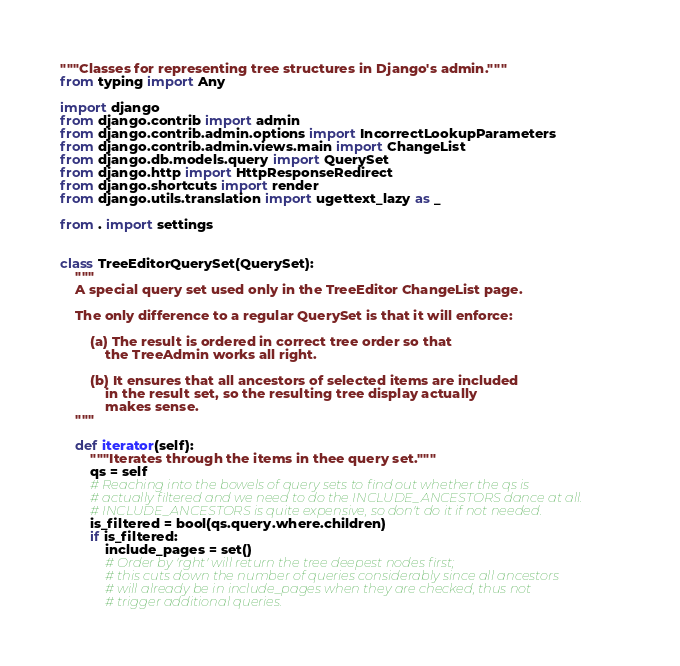<code> <loc_0><loc_0><loc_500><loc_500><_Python_>"""Classes for representing tree structures in Django's admin."""
from typing import Any

import django
from django.contrib import admin
from django.contrib.admin.options import IncorrectLookupParameters
from django.contrib.admin.views.main import ChangeList
from django.db.models.query import QuerySet
from django.http import HttpResponseRedirect
from django.shortcuts import render
from django.utils.translation import ugettext_lazy as _

from . import settings


class TreeEditorQuerySet(QuerySet):
    """
    A special query set used only in the TreeEditor ChangeList page.

    The only difference to a regular QuerySet is that it will enforce:

        (a) The result is ordered in correct tree order so that
            the TreeAdmin works all right.

        (b) It ensures that all ancestors of selected items are included
            in the result set, so the resulting tree display actually
            makes sense.
    """

    def iterator(self):
        """Iterates through the items in thee query set."""
        qs = self
        # Reaching into the bowels of query sets to find out whether the qs is
        # actually filtered and we need to do the INCLUDE_ANCESTORS dance at all.
        # INCLUDE_ANCESTORS is quite expensive, so don't do it if not needed.
        is_filtered = bool(qs.query.where.children)
        if is_filtered:
            include_pages = set()
            # Order by 'rght' will return the tree deepest nodes first;
            # this cuts down the number of queries considerably since all ancestors
            # will already be in include_pages when they are checked, thus not
            # trigger additional queries.</code> 